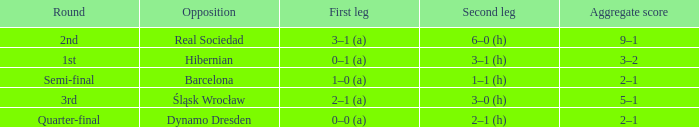Who were the opposition in the quarter-final? Dynamo Dresden. 